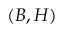Convert formula to latex. <formula><loc_0><loc_0><loc_500><loc_500>( B , H )</formula> 